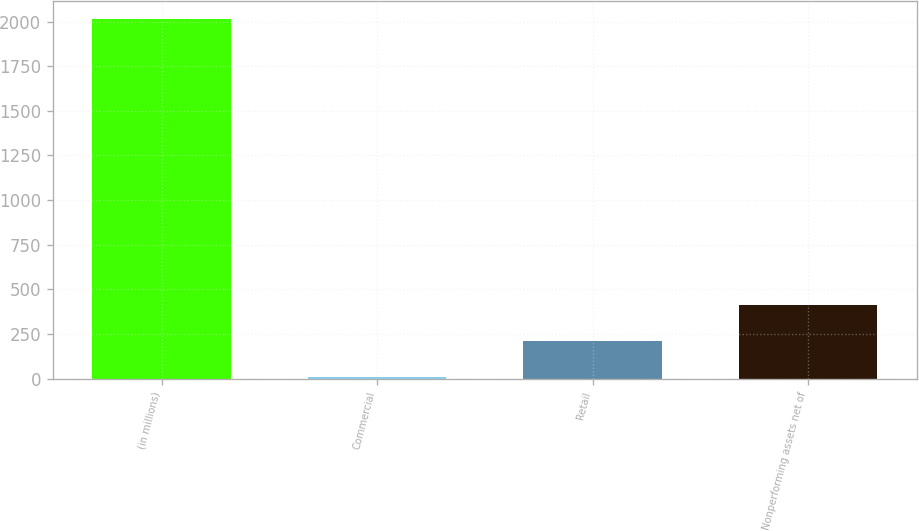Convert chart. <chart><loc_0><loc_0><loc_500><loc_500><bar_chart><fcel>(in millions)<fcel>Commercial<fcel>Retail<fcel>Nonperforming assets net of<nl><fcel>2013<fcel>10<fcel>210.3<fcel>410.6<nl></chart> 